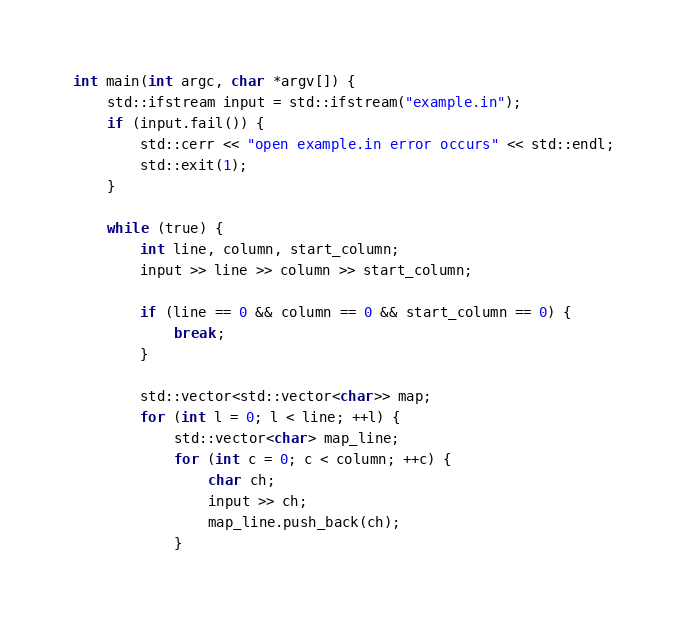<code> <loc_0><loc_0><loc_500><loc_500><_C++_>

int main(int argc, char *argv[]) {
    std::ifstream input = std::ifstream("example.in");
    if (input.fail()) {
        std::cerr << "open example.in error occurs" << std::endl;
        std::exit(1);
    }

    while (true) {
        int line, column, start_column;
        input >> line >> column >> start_column;

        if (line == 0 && column == 0 && start_column == 0) {
            break;
        }

        std::vector<std::vector<char>> map;
        for (int l = 0; l < line; ++l) {
            std::vector<char> map_line;
            for (int c = 0; c < column; ++c) {
                char ch;
                input >> ch;
                map_line.push_back(ch);
            }</code> 